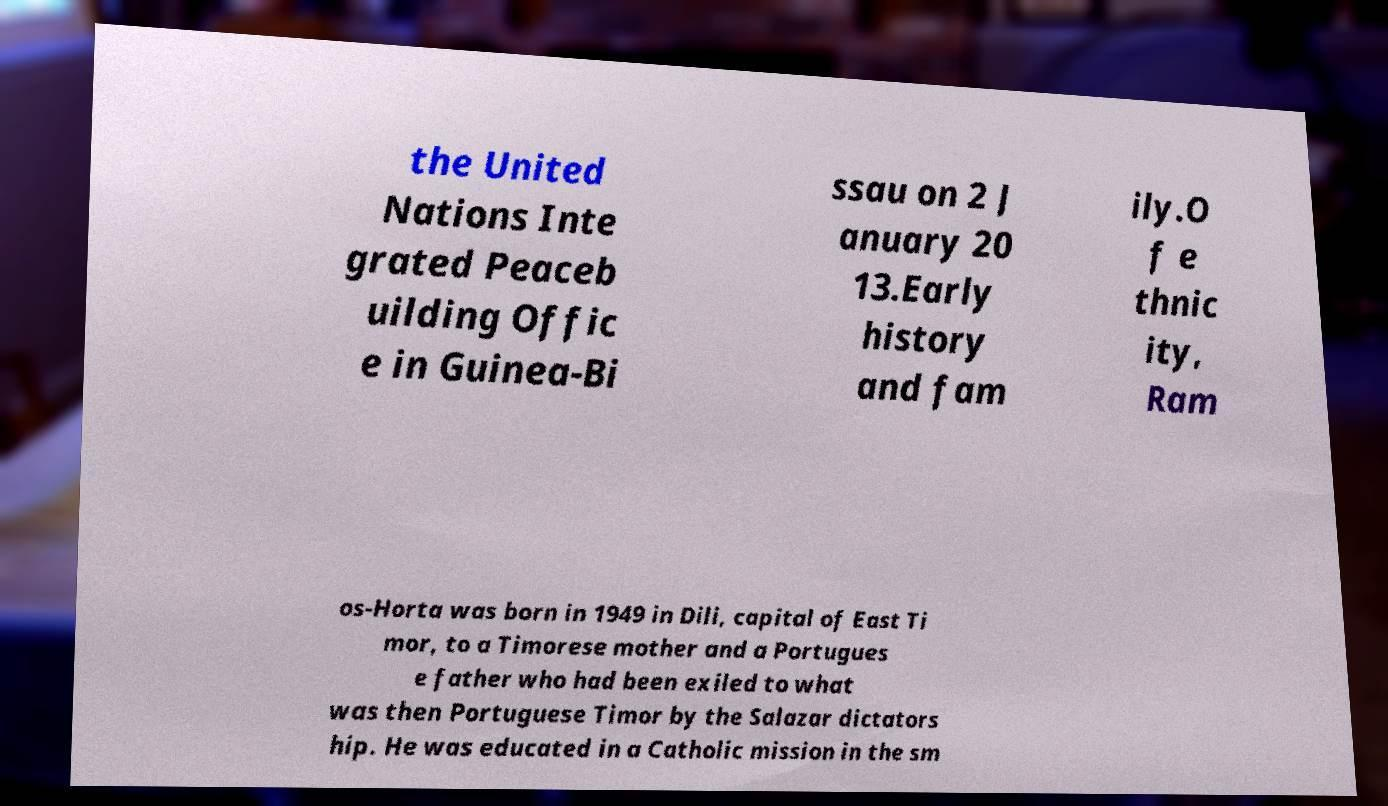I need the written content from this picture converted into text. Can you do that? the United Nations Inte grated Peaceb uilding Offic e in Guinea-Bi ssau on 2 J anuary 20 13.Early history and fam ily.O f e thnic ity, Ram os-Horta was born in 1949 in Dili, capital of East Ti mor, to a Timorese mother and a Portugues e father who had been exiled to what was then Portuguese Timor by the Salazar dictators hip. He was educated in a Catholic mission in the sm 